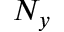Convert formula to latex. <formula><loc_0><loc_0><loc_500><loc_500>N _ { y }</formula> 